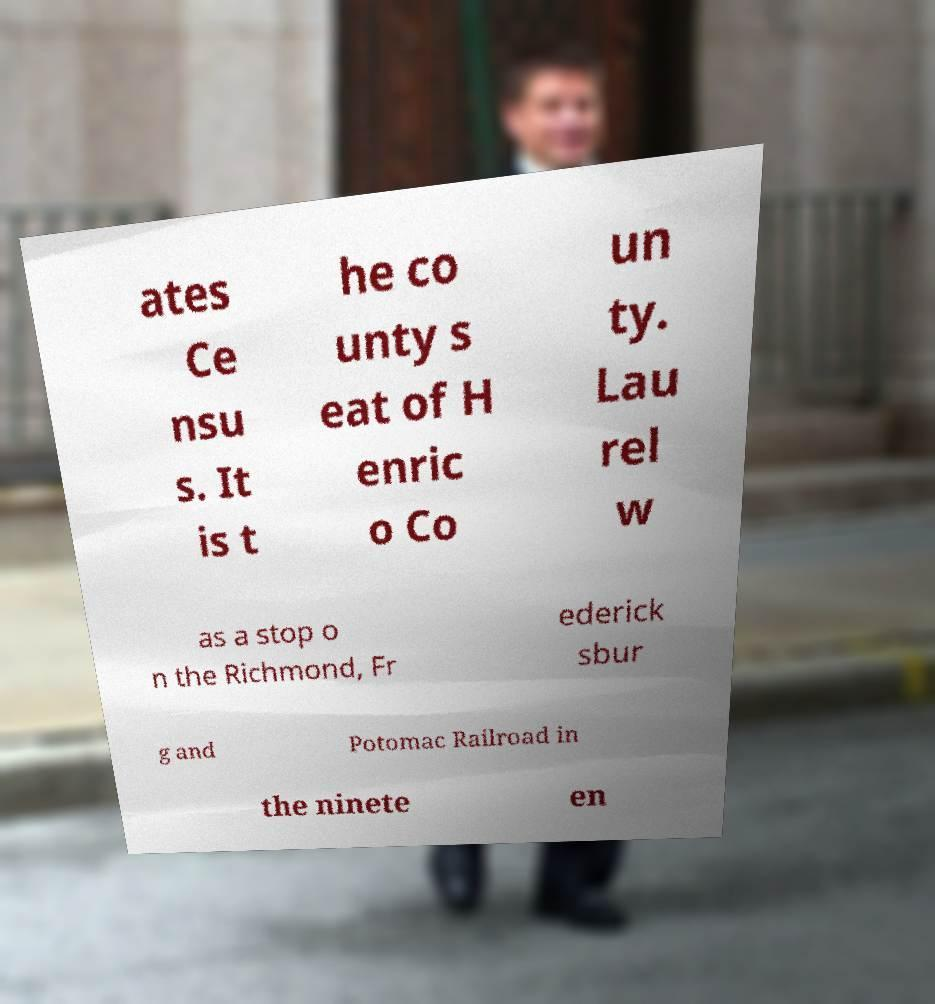Please identify and transcribe the text found in this image. ates Ce nsu s. It is t he co unty s eat of H enric o Co un ty. Lau rel w as a stop o n the Richmond, Fr ederick sbur g and Potomac Railroad in the ninete en 